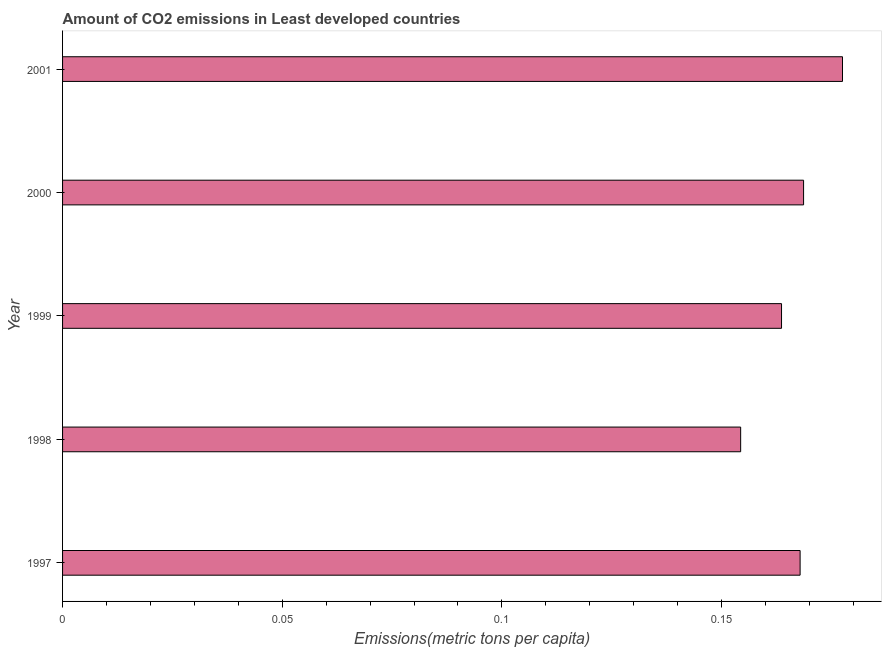Does the graph contain any zero values?
Your response must be concise. No. What is the title of the graph?
Keep it short and to the point. Amount of CO2 emissions in Least developed countries. What is the label or title of the X-axis?
Ensure brevity in your answer.  Emissions(metric tons per capita). What is the label or title of the Y-axis?
Give a very brief answer. Year. What is the amount of co2 emissions in 2000?
Offer a very short reply. 0.17. Across all years, what is the maximum amount of co2 emissions?
Ensure brevity in your answer.  0.18. Across all years, what is the minimum amount of co2 emissions?
Give a very brief answer. 0.15. In which year was the amount of co2 emissions maximum?
Your answer should be compact. 2001. What is the sum of the amount of co2 emissions?
Make the answer very short. 0.83. What is the difference between the amount of co2 emissions in 1998 and 1999?
Make the answer very short. -0.01. What is the average amount of co2 emissions per year?
Your answer should be compact. 0.17. What is the median amount of co2 emissions?
Provide a succinct answer. 0.17. In how many years, is the amount of co2 emissions greater than 0.05 metric tons per capita?
Offer a terse response. 5. What is the ratio of the amount of co2 emissions in 1998 to that in 1999?
Your response must be concise. 0.94. What is the difference between the highest and the second highest amount of co2 emissions?
Provide a short and direct response. 0.01. Is the sum of the amount of co2 emissions in 1999 and 2000 greater than the maximum amount of co2 emissions across all years?
Offer a very short reply. Yes. What is the difference between the highest and the lowest amount of co2 emissions?
Your response must be concise. 0.02. In how many years, is the amount of co2 emissions greater than the average amount of co2 emissions taken over all years?
Provide a succinct answer. 3. Are all the bars in the graph horizontal?
Make the answer very short. Yes. How many years are there in the graph?
Provide a succinct answer. 5. Are the values on the major ticks of X-axis written in scientific E-notation?
Provide a succinct answer. No. What is the Emissions(metric tons per capita) in 1997?
Give a very brief answer. 0.17. What is the Emissions(metric tons per capita) in 1998?
Provide a succinct answer. 0.15. What is the Emissions(metric tons per capita) in 1999?
Provide a succinct answer. 0.16. What is the Emissions(metric tons per capita) in 2000?
Keep it short and to the point. 0.17. What is the Emissions(metric tons per capita) in 2001?
Your answer should be very brief. 0.18. What is the difference between the Emissions(metric tons per capita) in 1997 and 1998?
Offer a very short reply. 0.01. What is the difference between the Emissions(metric tons per capita) in 1997 and 1999?
Provide a short and direct response. 0. What is the difference between the Emissions(metric tons per capita) in 1997 and 2000?
Provide a succinct answer. -0. What is the difference between the Emissions(metric tons per capita) in 1997 and 2001?
Your response must be concise. -0.01. What is the difference between the Emissions(metric tons per capita) in 1998 and 1999?
Your answer should be compact. -0.01. What is the difference between the Emissions(metric tons per capita) in 1998 and 2000?
Give a very brief answer. -0.01. What is the difference between the Emissions(metric tons per capita) in 1998 and 2001?
Your answer should be compact. -0.02. What is the difference between the Emissions(metric tons per capita) in 1999 and 2000?
Make the answer very short. -0.01. What is the difference between the Emissions(metric tons per capita) in 1999 and 2001?
Your response must be concise. -0.01. What is the difference between the Emissions(metric tons per capita) in 2000 and 2001?
Give a very brief answer. -0.01. What is the ratio of the Emissions(metric tons per capita) in 1997 to that in 1998?
Ensure brevity in your answer.  1.09. What is the ratio of the Emissions(metric tons per capita) in 1997 to that in 2001?
Provide a short and direct response. 0.95. What is the ratio of the Emissions(metric tons per capita) in 1998 to that in 1999?
Provide a succinct answer. 0.94. What is the ratio of the Emissions(metric tons per capita) in 1998 to that in 2000?
Your answer should be compact. 0.92. What is the ratio of the Emissions(metric tons per capita) in 1998 to that in 2001?
Offer a terse response. 0.87. What is the ratio of the Emissions(metric tons per capita) in 1999 to that in 2001?
Ensure brevity in your answer.  0.92. What is the ratio of the Emissions(metric tons per capita) in 2000 to that in 2001?
Provide a short and direct response. 0.95. 